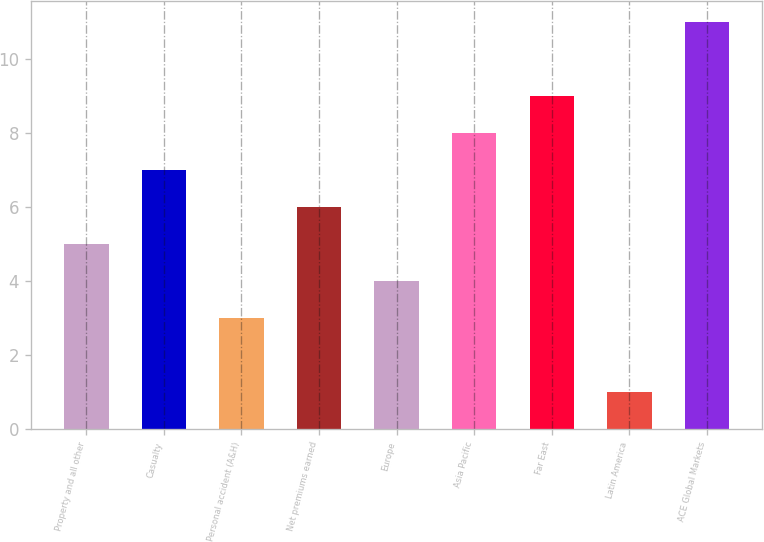<chart> <loc_0><loc_0><loc_500><loc_500><bar_chart><fcel>Property and all other<fcel>Casualty<fcel>Personal accident (A&H)<fcel>Net premiums earned<fcel>Europe<fcel>Asia Pacific<fcel>Far East<fcel>Latin America<fcel>ACE Global Markets<nl><fcel>5<fcel>7<fcel>3<fcel>6<fcel>4<fcel>8<fcel>9<fcel>1<fcel>11<nl></chart> 